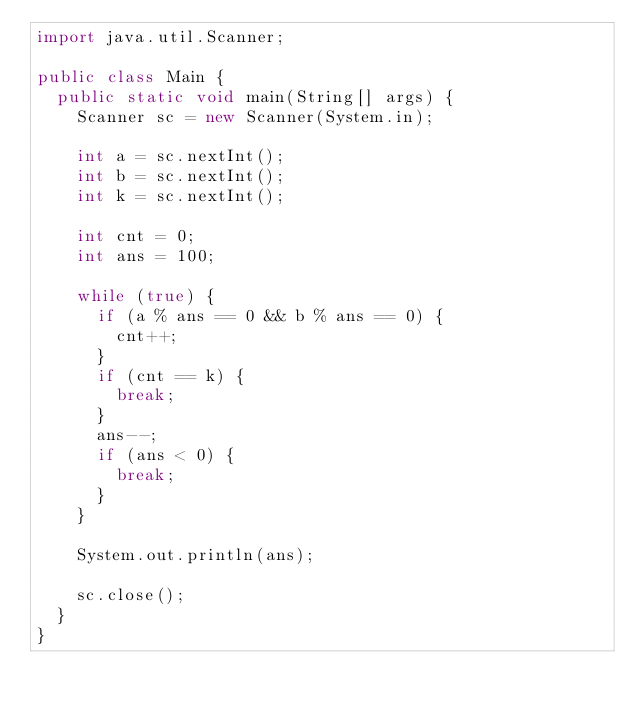<code> <loc_0><loc_0><loc_500><loc_500><_Java_>import java.util.Scanner;

public class Main {
	public static void main(String[] args) {
		Scanner sc = new Scanner(System.in);

		int a = sc.nextInt();
		int b = sc.nextInt();
		int k = sc.nextInt();

		int cnt = 0;
		int ans = 100;

		while (true) {
			if (a % ans == 0 && b % ans == 0) {
				cnt++;
			}
			if (cnt == k) {
				break;
			}
			ans--;
			if (ans < 0) {
				break;
			}
		}

		System.out.println(ans);

		sc.close();
	}
}
</code> 